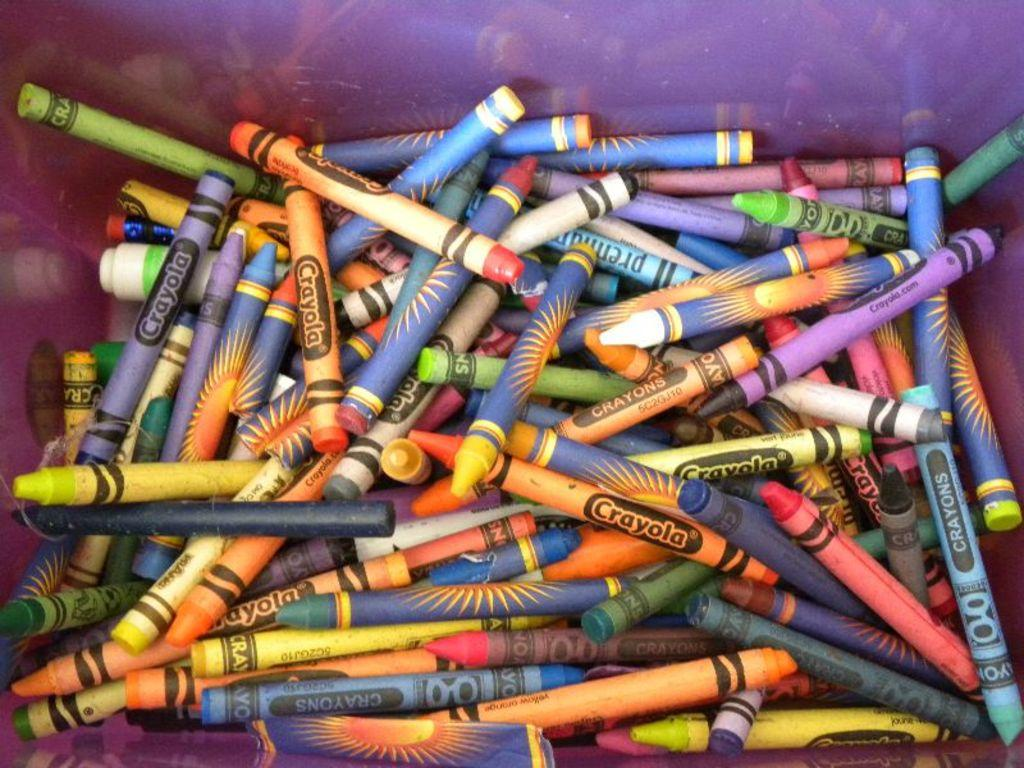<image>
Relay a brief, clear account of the picture shown. A box full of crayons with many from the brand Crayola. 